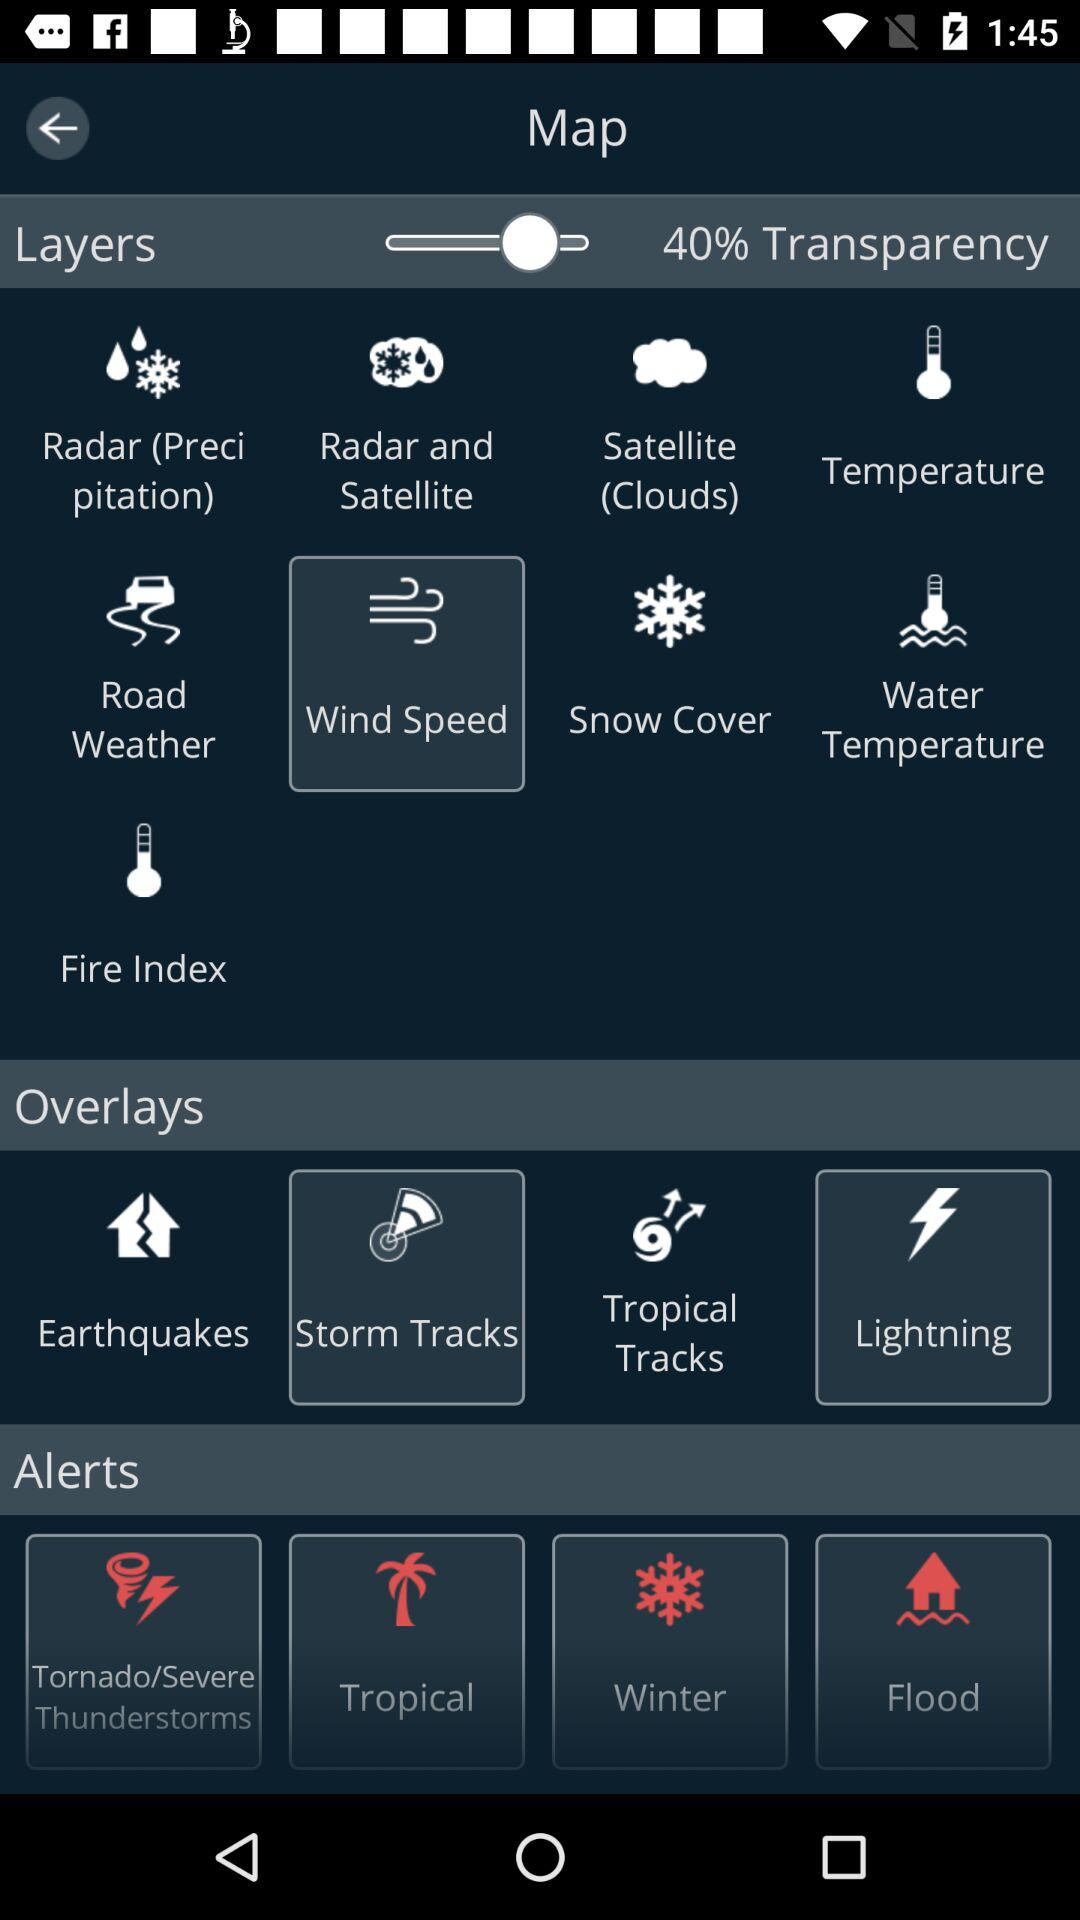How many alerts are available for the user to select?
Answer the question using a single word or phrase. 4 